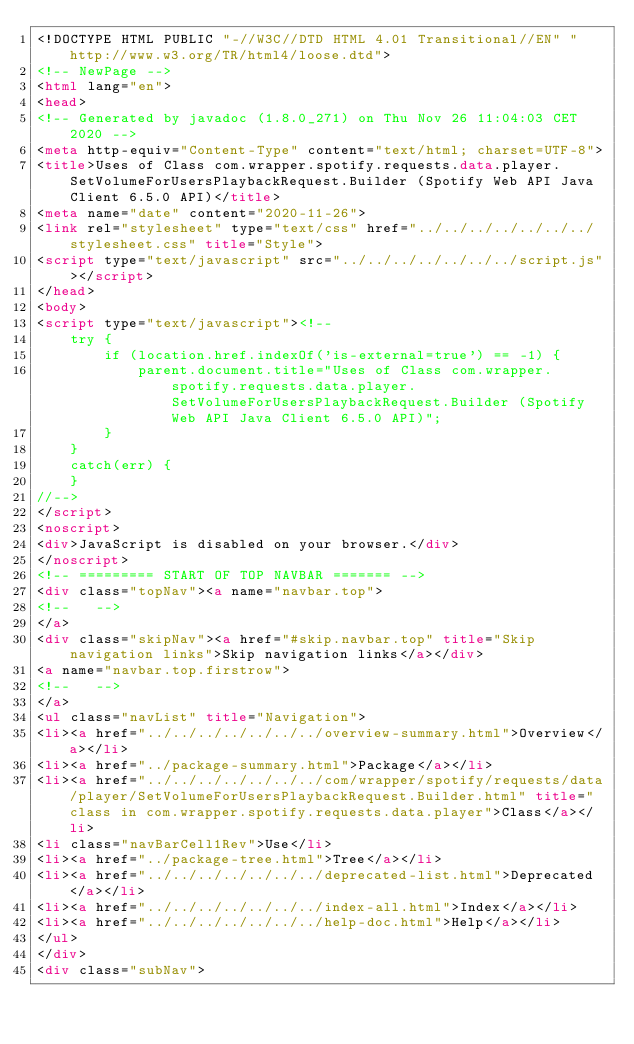Convert code to text. <code><loc_0><loc_0><loc_500><loc_500><_HTML_><!DOCTYPE HTML PUBLIC "-//W3C//DTD HTML 4.01 Transitional//EN" "http://www.w3.org/TR/html4/loose.dtd">
<!-- NewPage -->
<html lang="en">
<head>
<!-- Generated by javadoc (1.8.0_271) on Thu Nov 26 11:04:03 CET 2020 -->
<meta http-equiv="Content-Type" content="text/html; charset=UTF-8">
<title>Uses of Class com.wrapper.spotify.requests.data.player.SetVolumeForUsersPlaybackRequest.Builder (Spotify Web API Java Client 6.5.0 API)</title>
<meta name="date" content="2020-11-26">
<link rel="stylesheet" type="text/css" href="../../../../../../../stylesheet.css" title="Style">
<script type="text/javascript" src="../../../../../../../script.js"></script>
</head>
<body>
<script type="text/javascript"><!--
    try {
        if (location.href.indexOf('is-external=true') == -1) {
            parent.document.title="Uses of Class com.wrapper.spotify.requests.data.player.SetVolumeForUsersPlaybackRequest.Builder (Spotify Web API Java Client 6.5.0 API)";
        }
    }
    catch(err) {
    }
//-->
</script>
<noscript>
<div>JavaScript is disabled on your browser.</div>
</noscript>
<!-- ========= START OF TOP NAVBAR ======= -->
<div class="topNav"><a name="navbar.top">
<!--   -->
</a>
<div class="skipNav"><a href="#skip.navbar.top" title="Skip navigation links">Skip navigation links</a></div>
<a name="navbar.top.firstrow">
<!--   -->
</a>
<ul class="navList" title="Navigation">
<li><a href="../../../../../../../overview-summary.html">Overview</a></li>
<li><a href="../package-summary.html">Package</a></li>
<li><a href="../../../../../../../com/wrapper/spotify/requests/data/player/SetVolumeForUsersPlaybackRequest.Builder.html" title="class in com.wrapper.spotify.requests.data.player">Class</a></li>
<li class="navBarCell1Rev">Use</li>
<li><a href="../package-tree.html">Tree</a></li>
<li><a href="../../../../../../../deprecated-list.html">Deprecated</a></li>
<li><a href="../../../../../../../index-all.html">Index</a></li>
<li><a href="../../../../../../../help-doc.html">Help</a></li>
</ul>
</div>
<div class="subNav"></code> 